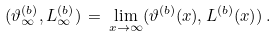Convert formula to latex. <formula><loc_0><loc_0><loc_500><loc_500>( \vartheta ^ { ( b ) } _ { \infty } , L ^ { ( b ) } _ { \infty } ) \, = \, \lim _ { x \rightarrow \infty } ( \vartheta ^ { ( b ) } ( x ) , L ^ { ( b ) } ( x ) ) \, .</formula> 